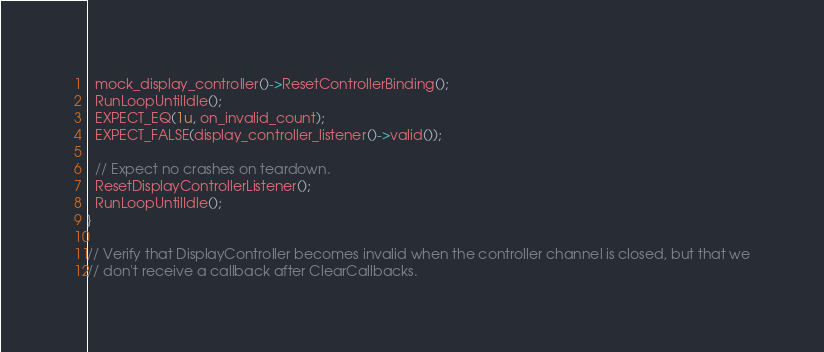<code> <loc_0><loc_0><loc_500><loc_500><_C++_>  mock_display_controller()->ResetControllerBinding();
  RunLoopUntilIdle();
  EXPECT_EQ(1u, on_invalid_count);
  EXPECT_FALSE(display_controller_listener()->valid());

  // Expect no crashes on teardown.
  ResetDisplayControllerListener();
  RunLoopUntilIdle();
}

// Verify that DisplayController becomes invalid when the controller channel is closed, but that we
// don't receive a callback after ClearCallbacks.</code> 